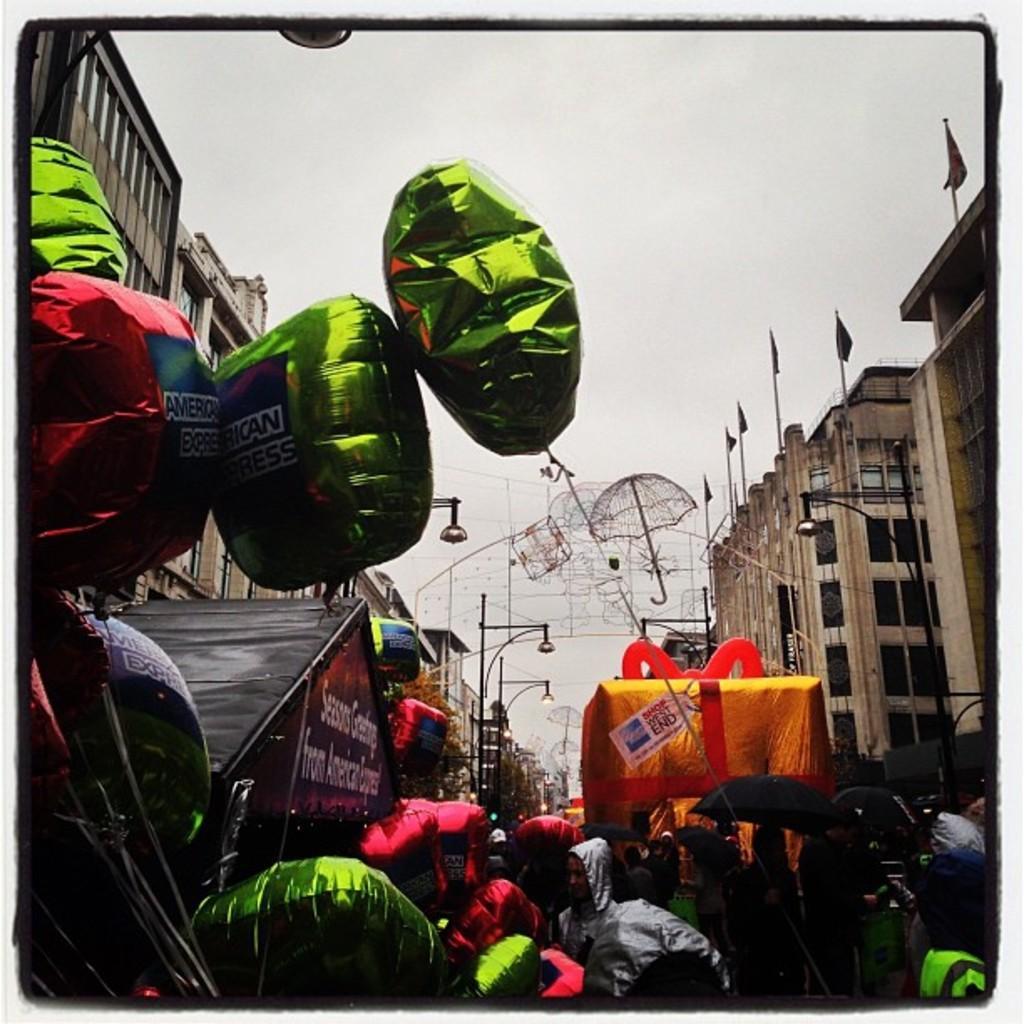Please provide a concise description of this image. This is a photo. In this picture we can see the buildings, poles, lights, flags, umbrella, tents, boards, balloons. At the bottom of the image we can see some people are standing. At the top of the image we can see the sky and light. 